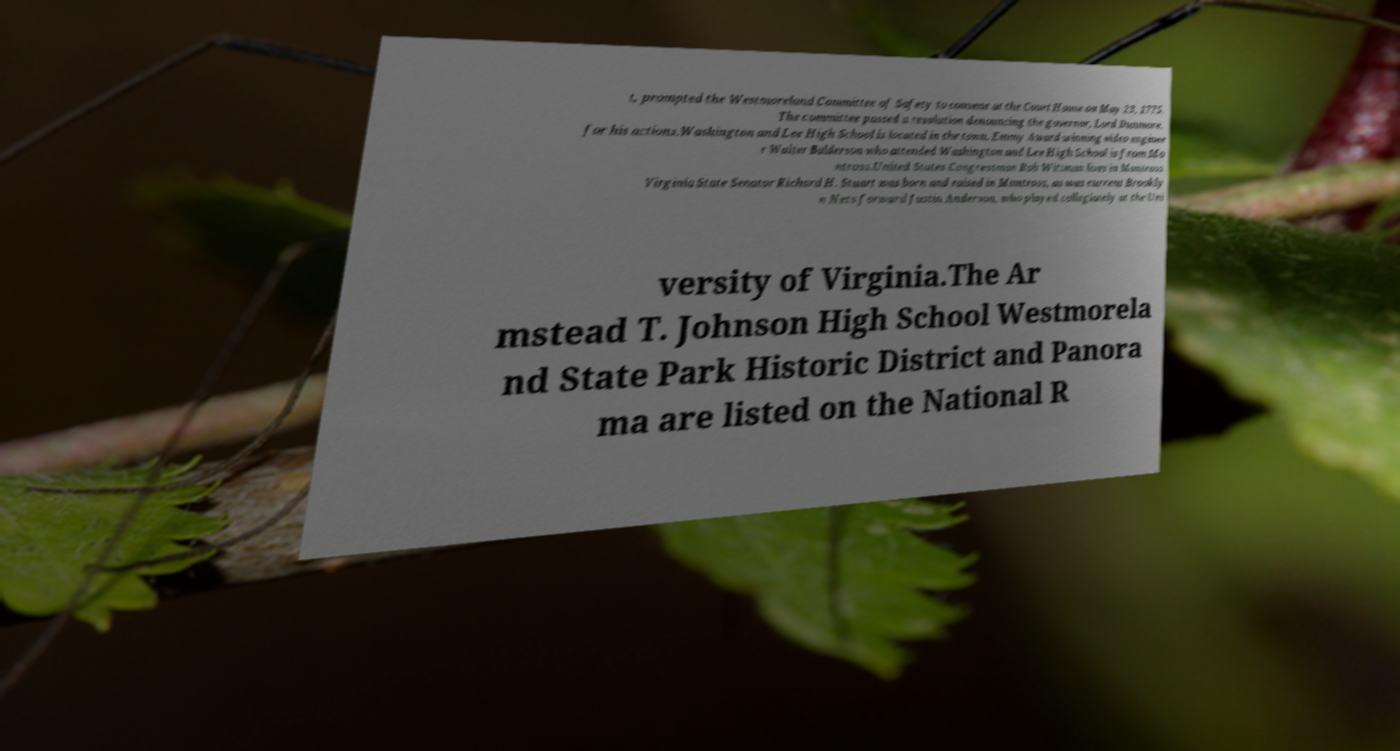Can you accurately transcribe the text from the provided image for me? t, prompted the Westmoreland Committee of Safety to convene at the Court House on May 23, 1775. The committee passed a resolution denouncing the governor, Lord Dunmore, for his actions.Washington and Lee High School is located in the town. Emmy Award-winning video enginee r Walter Balderson who attended Washington and Lee High School is from Mo ntross.United States Congressman Rob Wittman lives in Montross. Virginia State Senator Richard H. Stuart was born and raised in Montross, as was current Brookly n Nets forward Justin Anderson, who played collegiately at the Uni versity of Virginia.The Ar mstead T. Johnson High School Westmorela nd State Park Historic District and Panora ma are listed on the National R 